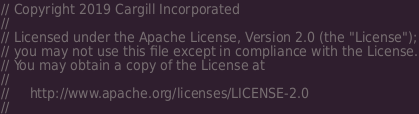Convert code to text. <code><loc_0><loc_0><loc_500><loc_500><_Rust_>// Copyright 2019 Cargill Incorporated
//
// Licensed under the Apache License, Version 2.0 (the "License");
// you may not use this file except in compliance with the License.
// You may obtain a copy of the License at
//
//     http://www.apache.org/licenses/LICENSE-2.0
//</code> 